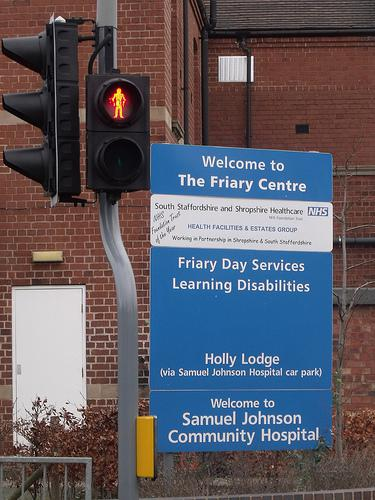Question: where is brick?
Choices:
A. On the road.
B. On the sidewalk.
C. On the building.
D. On the post.
Answer with the letter. Answer: C Question: where is the picture taken?
Choices:
A. Street.
B. Park.
C. Hotel Lobby.
D. In a metropolitan area.
Answer with the letter. Answer: D Question: what is blue?
Choices:
A. The sky.
B. The fence.
C. A sign.
D. The house.
Answer with the letter. Answer: C 